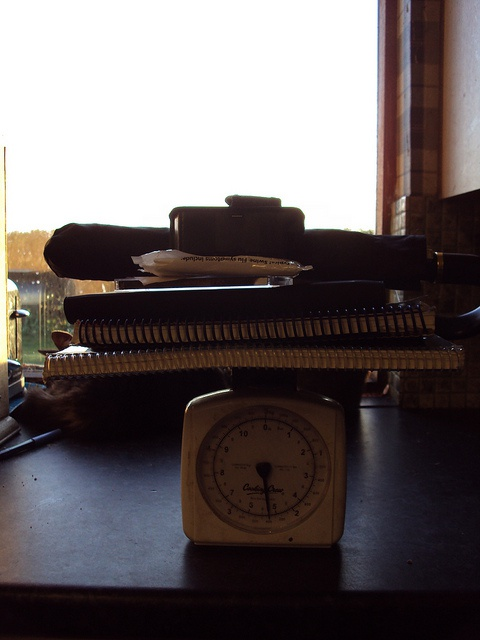Describe the objects in this image and their specific colors. I can see clock in black, maroon, and white tones, book in white, black, and maroon tones, book in white, black, maroon, and gray tones, and book in white, black, maroon, and gray tones in this image. 